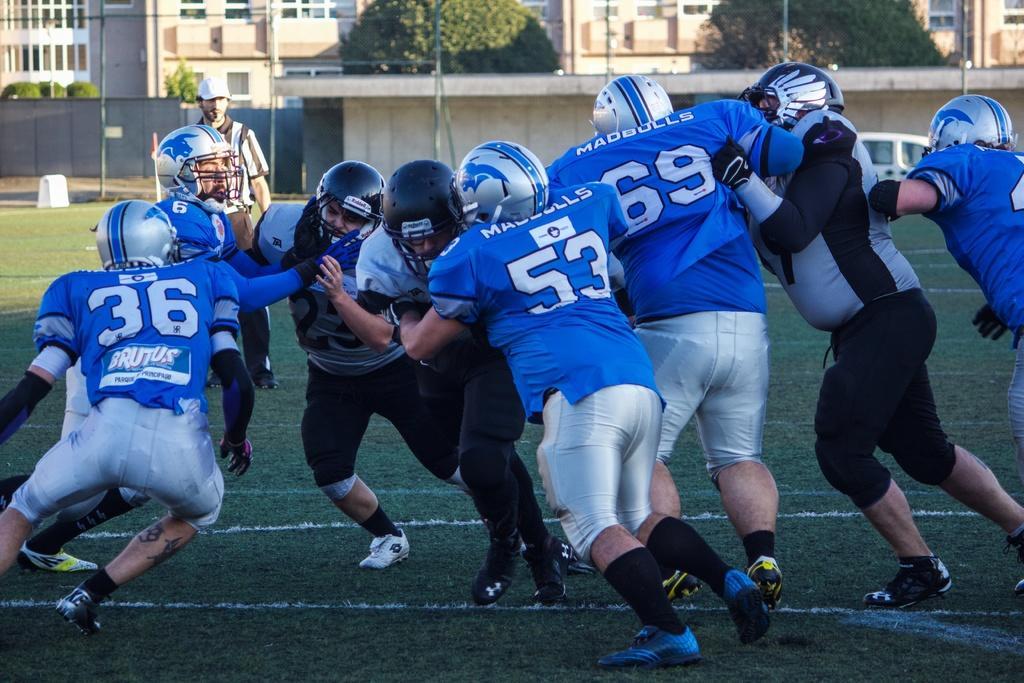Describe this image in one or two sentences. In this picture I can see few men playing a game and I can see a man standing in the back, he looks like a umpire and I can see buildings and trees in the back and I can see grass on the ground and a car. 